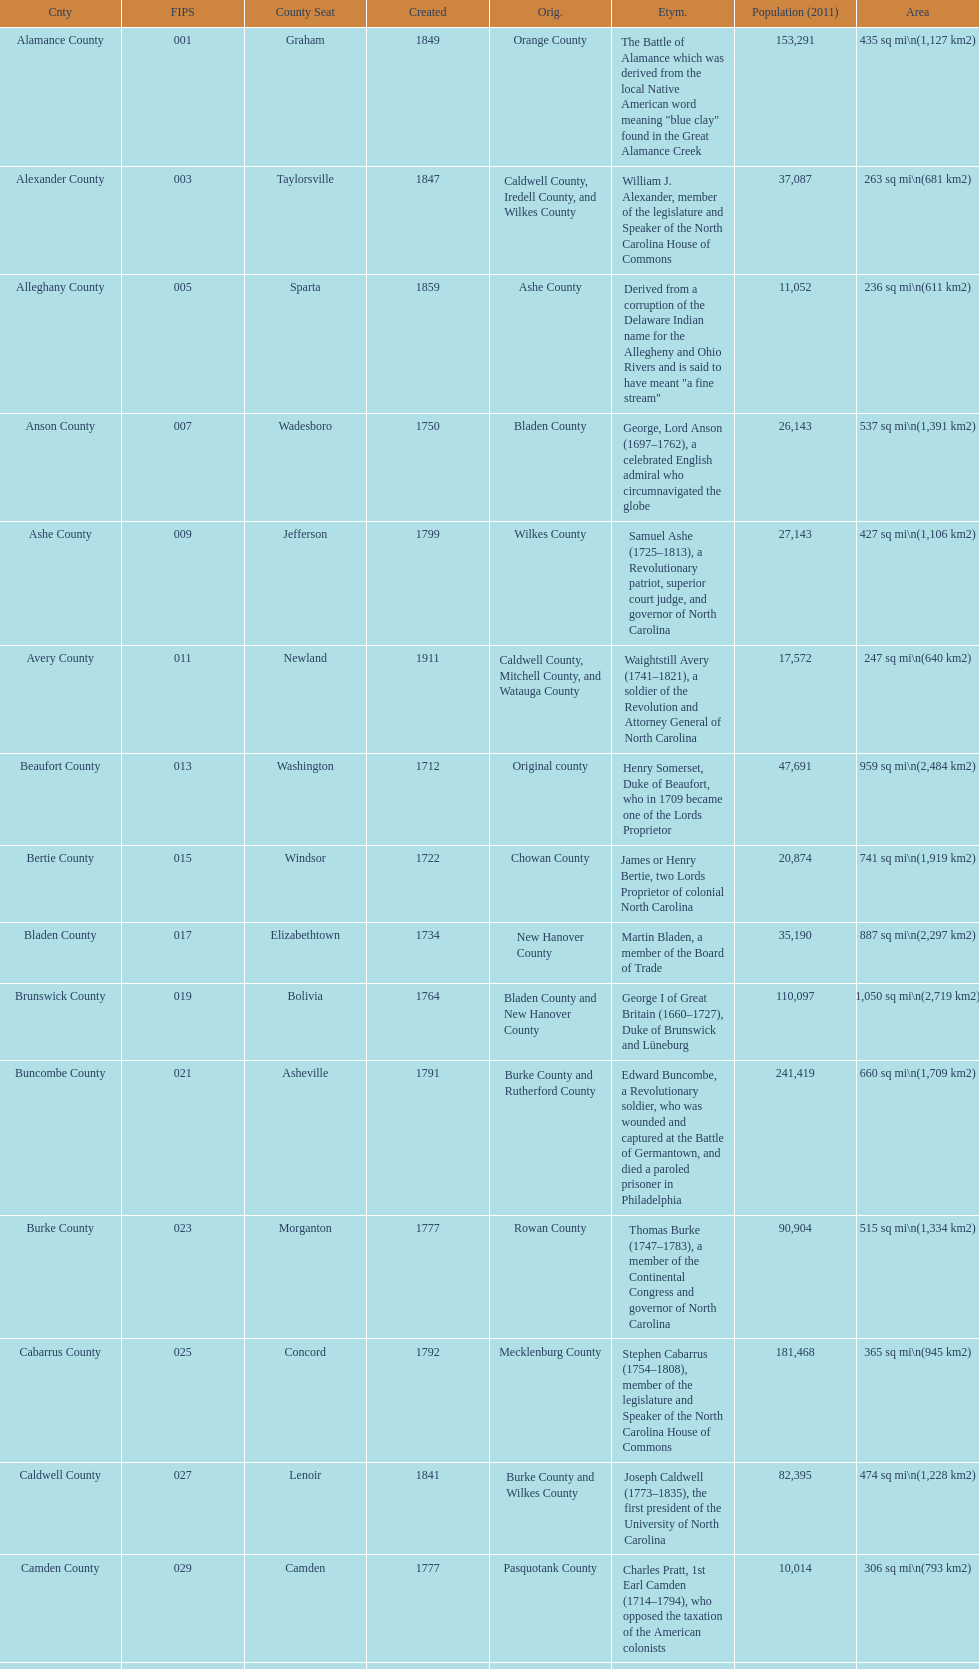Which county covers the most area? Dare County. 